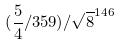Convert formula to latex. <formula><loc_0><loc_0><loc_500><loc_500>( \frac { 5 } { 4 } / 3 5 9 ) / \sqrt { 8 } ^ { 1 4 6 }</formula> 